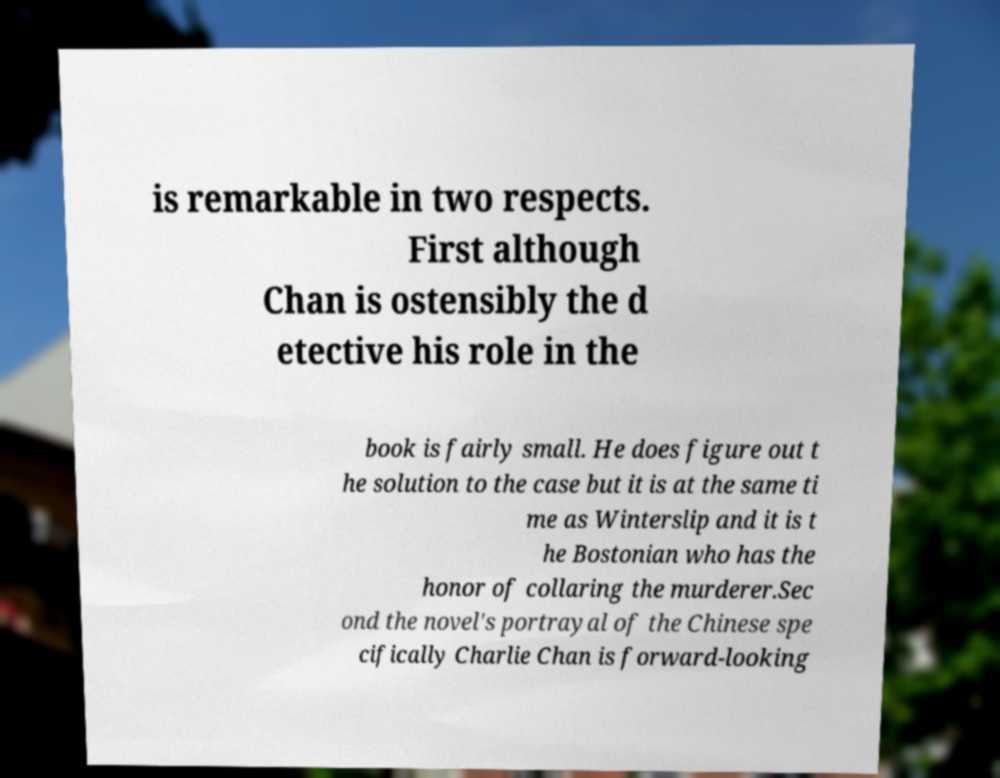For documentation purposes, I need the text within this image transcribed. Could you provide that? is remarkable in two respects. First although Chan is ostensibly the d etective his role in the book is fairly small. He does figure out t he solution to the case but it is at the same ti me as Winterslip and it is t he Bostonian who has the honor of collaring the murderer.Sec ond the novel's portrayal of the Chinese spe cifically Charlie Chan is forward-looking 